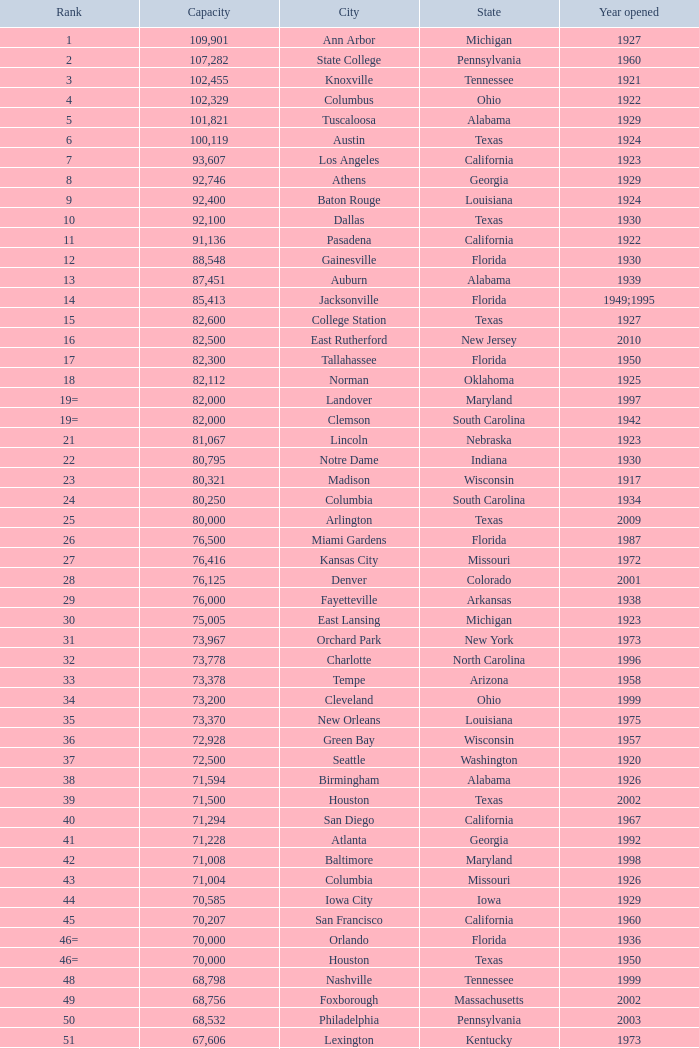What was the year opened for North Carolina with a smaller than 21,500 capacity? 1926.0. Would you be able to parse every entry in this table? {'header': ['Rank', 'Capacity', 'City', 'State', 'Year opened'], 'rows': [['1', '109,901', 'Ann Arbor', 'Michigan', '1927'], ['2', '107,282', 'State College', 'Pennsylvania', '1960'], ['3', '102,455', 'Knoxville', 'Tennessee', '1921'], ['4', '102,329', 'Columbus', 'Ohio', '1922'], ['5', '101,821', 'Tuscaloosa', 'Alabama', '1929'], ['6', '100,119', 'Austin', 'Texas', '1924'], ['7', '93,607', 'Los Angeles', 'California', '1923'], ['8', '92,746', 'Athens', 'Georgia', '1929'], ['9', '92,400', 'Baton Rouge', 'Louisiana', '1924'], ['10', '92,100', 'Dallas', 'Texas', '1930'], ['11', '91,136', 'Pasadena', 'California', '1922'], ['12', '88,548', 'Gainesville', 'Florida', '1930'], ['13', '87,451', 'Auburn', 'Alabama', '1939'], ['14', '85,413', 'Jacksonville', 'Florida', '1949;1995'], ['15', '82,600', 'College Station', 'Texas', '1927'], ['16', '82,500', 'East Rutherford', 'New Jersey', '2010'], ['17', '82,300', 'Tallahassee', 'Florida', '1950'], ['18', '82,112', 'Norman', 'Oklahoma', '1925'], ['19=', '82,000', 'Landover', 'Maryland', '1997'], ['19=', '82,000', 'Clemson', 'South Carolina', '1942'], ['21', '81,067', 'Lincoln', 'Nebraska', '1923'], ['22', '80,795', 'Notre Dame', 'Indiana', '1930'], ['23', '80,321', 'Madison', 'Wisconsin', '1917'], ['24', '80,250', 'Columbia', 'South Carolina', '1934'], ['25', '80,000', 'Arlington', 'Texas', '2009'], ['26', '76,500', 'Miami Gardens', 'Florida', '1987'], ['27', '76,416', 'Kansas City', 'Missouri', '1972'], ['28', '76,125', 'Denver', 'Colorado', '2001'], ['29', '76,000', 'Fayetteville', 'Arkansas', '1938'], ['30', '75,005', 'East Lansing', 'Michigan', '1923'], ['31', '73,967', 'Orchard Park', 'New York', '1973'], ['32', '73,778', 'Charlotte', 'North Carolina', '1996'], ['33', '73,378', 'Tempe', 'Arizona', '1958'], ['34', '73,200', 'Cleveland', 'Ohio', '1999'], ['35', '73,370', 'New Orleans', 'Louisiana', '1975'], ['36', '72,928', 'Green Bay', 'Wisconsin', '1957'], ['37', '72,500', 'Seattle', 'Washington', '1920'], ['38', '71,594', 'Birmingham', 'Alabama', '1926'], ['39', '71,500', 'Houston', 'Texas', '2002'], ['40', '71,294', 'San Diego', 'California', '1967'], ['41', '71,228', 'Atlanta', 'Georgia', '1992'], ['42', '71,008', 'Baltimore', 'Maryland', '1998'], ['43', '71,004', 'Columbia', 'Missouri', '1926'], ['44', '70,585', 'Iowa City', 'Iowa', '1929'], ['45', '70,207', 'San Francisco', 'California', '1960'], ['46=', '70,000', 'Orlando', 'Florida', '1936'], ['46=', '70,000', 'Houston', 'Texas', '1950'], ['48', '68,798', 'Nashville', 'Tennessee', '1999'], ['49', '68,756', 'Foxborough', 'Massachusetts', '2002'], ['50', '68,532', 'Philadelphia', 'Pennsylvania', '2003'], ['51', '67,606', 'Lexington', 'Kentucky', '1973'], ['52', '67,000', 'Seattle', 'Washington', '2002'], ['53', '66,965', 'St. Louis', 'Missouri', '1995'], ['54', '66,233', 'Blacksburg', 'Virginia', '1965'], ['55', '65,857', 'Tampa', 'Florida', '1998'], ['56', '65,790', 'Cincinnati', 'Ohio', '2000'], ['57', '65,050', 'Pittsburgh', 'Pennsylvania', '2001'], ['58=', '65,000', 'San Antonio', 'Texas', '1993'], ['58=', '65,000', 'Detroit', 'Michigan', '2002'], ['60', '64,269', 'New Haven', 'Connecticut', '1914'], ['61', '64,111', 'Minneapolis', 'Minnesota', '1982'], ['62', '64,045', 'Provo', 'Utah', '1964'], ['63', '63,400', 'Glendale', 'Arizona', '2006'], ['64', '63,026', 'Oakland', 'California', '1966'], ['65', '63,000', 'Indianapolis', 'Indiana', '2008'], ['65', '63.000', 'Chapel Hill', 'North Carolina', '1926'], ['66', '62,872', 'Champaign', 'Illinois', '1923'], ['67', '62,717', 'Berkeley', 'California', '1923'], ['68', '61,500', 'Chicago', 'Illinois', '1924;2003'], ['69', '62,500', 'West Lafayette', 'Indiana', '1924'], ['70', '62,380', 'Memphis', 'Tennessee', '1965'], ['71', '61,500', 'Charlottesville', 'Virginia', '1931'], ['72', '61,000', 'Lubbock', 'Texas', '1947'], ['73', '60,580', 'Oxford', 'Mississippi', '1915'], ['74', '60,540', 'Morgantown', 'West Virginia', '1980'], ['75', '60,492', 'Jackson', 'Mississippi', '1941'], ['76', '60,000', 'Stillwater', 'Oklahoma', '1920'], ['78', '57,803', 'Tucson', 'Arizona', '1928'], ['79', '57,583', 'Raleigh', 'North Carolina', '1966'], ['80', '56,692', 'Washington, D.C.', 'District of Columbia', '1961'], ['81=', '56,000', 'Los Angeles', 'California', '1962'], ['81=', '56,000', 'Louisville', 'Kentucky', '1998'], ['83', '55,082', 'Starkville', 'Mississippi', '1914'], ['84=', '55,000', 'Atlanta', 'Georgia', '1913'], ['84=', '55,000', 'Ames', 'Iowa', '1975'], ['86', '53,800', 'Eugene', 'Oregon', '1967'], ['87', '53,750', 'Boulder', 'Colorado', '1924'], ['88', '53,727', 'Little Rock', 'Arkansas', '1948'], ['89', '53,500', 'Bloomington', 'Indiana', '1960'], ['90', '52,593', 'Philadelphia', 'Pennsylvania', '1895'], ['91', '52,480', 'Colorado Springs', 'Colorado', '1962'], ['92', '52,454', 'Piscataway', 'New Jersey', '1994'], ['93', '52,200', 'Manhattan', 'Kansas', '1968'], ['94=', '51,500', 'College Park', 'Maryland', '1950'], ['94=', '51,500', 'El Paso', 'Texas', '1963'], ['96', '50,832', 'Shreveport', 'Louisiana', '1925'], ['97', '50,805', 'Minneapolis', 'Minnesota', '2009'], ['98', '50,445', 'Denver', 'Colorado', '1995'], ['99', '50,291', 'Bronx', 'New York', '2009'], ['100', '50,096', 'Atlanta', 'Georgia', '1996'], ['101', '50,071', 'Lawrence', 'Kansas', '1921'], ['102=', '50,000', 'Honolulu', 'Hawai ʻ i', '1975'], ['102=', '50,000', 'Greenville', 'North Carolina', '1963'], ['102=', '50,000', 'Waco', 'Texas', '1950'], ['102=', '50,000', 'Stanford', 'California', '1921;2006'], ['106', '49,262', 'Syracuse', 'New York', '1980'], ['107', '49,115', 'Arlington', 'Texas', '1994'], ['108', '49,033', 'Phoenix', 'Arizona', '1998'], ['109', '48,876', 'Baltimore', 'Maryland', '1992'], ['110', '47,130', 'Evanston', 'Illinois', '1996'], ['111', '47,116', 'Seattle', 'Washington', '1999'], ['112', '46,861', 'St. Louis', 'Missouri', '2006'], ['113', '45,674', 'Corvallis', 'Oregon', '1953'], ['114', '45,634', 'Salt Lake City', 'Utah', '1998'], ['115', '45,301', 'Orlando', 'Florida', '2007'], ['116', '45,050', 'Anaheim', 'California', '1966'], ['117', '44,500', 'Chestnut Hill', 'Massachusetts', '1957'], ['118', '44,008', 'Fort Worth', 'Texas', '1930'], ['119', '43,647', 'Philadelphia', 'Pennsylvania', '2004'], ['120', '43,545', 'Cleveland', 'Ohio', '1994'], ['121', '42,445', 'San Diego', 'California', '2004'], ['122', '42,059', 'Cincinnati', 'Ohio', '2003'], ['123', '41,900', 'Milwaukee', 'Wisconsin', '2001'], ['124', '41,888', 'Washington, D.C.', 'District of Columbia', '2008'], ['125', '41,800', 'Flushing, New York', 'New York', '2009'], ['126', '41,782', 'Detroit', 'Michigan', '2000'], ['127', '41,503', 'San Francisco', 'California', '2000'], ['128', '41,160', 'Chicago', 'Illinois', '1914'], ['129', '41,031', 'Fresno', 'California', '1980'], ['130', '40,950', 'Houston', 'Texas', '2000'], ['131', '40,646', 'Mobile', 'Alabama', '1948'], ['132', '40,615', 'Chicago', 'Illinois', '1991'], ['133', '40,094', 'Albuquerque', 'New Mexico', '1960'], ['134=', '40,000', 'South Williamsport', 'Pennsylvania', '1959'], ['134=', '40,000', 'East Hartford', 'Connecticut', '2003'], ['134=', '40,000', 'West Point', 'New York', '1924'], ['137', '39,790', 'Nashville', 'Tennessee', '1922'], ['138', '39,504', 'Minneapolis', 'Minnesota', '2010'], ['139', '39,000', 'Kansas City', 'Missouri', '1973'], ['140', '38,496', 'Pittsburgh', 'Pennsylvania', '2001'], ['141', '38,019', 'Huntington', 'West Virginia', '1991'], ['142', '37,402', 'Boston', 'Massachusetts', '1912'], ['143=', '37,000', 'Boise', 'Idaho', '1970'], ['143=', '37,000', 'Miami', 'Florida', '2012'], ['145', '36,973', 'St. Petersburg', 'Florida', '1990'], ['146', '36,800', 'Whitney', 'Nevada', '1971'], ['147', '36,000', 'Hattiesburg', 'Mississippi', '1932'], ['148', '35,117', 'Pullman', 'Washington', '1972'], ['149', '35,097', 'Cincinnati', 'Ohio', '1924'], ['150', '34,400', 'Fort Collins', 'Colorado', '1968'], ['151', '34,000', 'Annapolis', 'Maryland', '1959'], ['152', '33,941', 'Durham', 'North Carolina', '1929'], ['153', '32,580', 'Laramie', 'Wyoming', '1950'], ['154=', '32,000', 'University Park', 'Texas', '2000'], ['154=', '32,000', 'Houston', 'Texas', '1942'], ['156', '31,500', 'Winston-Salem', 'North Carolina', '1968'], ['157=', '31,000', 'Lafayette', 'Louisiana', '1971'], ['157=', '31,000', 'Akron', 'Ohio', '1940'], ['157=', '31,000', 'DeKalb', 'Illinois', '1965'], ['160', '30,964', 'Jonesboro', 'Arkansas', '1974'], ['161', '30,850', 'Denton', 'Texas', '2011'], ['162', '30,600', 'Ruston', 'Louisiana', '1960'], ['163', '30,456', 'San Jose', 'California', '1933'], ['164', '30,427', 'Monroe', 'Louisiana', '1978'], ['165', '30,343', 'Las Cruces', 'New Mexico', '1978'], ['166', '30,323', 'Allston', 'Massachusetts', '1903'], ['167', '30,295', 'Mount Pleasant', 'Michigan', '1972'], ['168=', '30,200', 'Ypsilanti', 'Michigan', '1969'], ['168=', '30,200', 'Kalamazoo', 'Michigan', '1939'], ['168=', '30,000', 'Boca Raton', 'Florida', '2011'], ['168=', '30,000', 'San Marcos', 'Texas', '1981'], ['168=', '30,000', 'Tulsa', 'Oklahoma', '1930'], ['168=', '30,000', 'Akron', 'Ohio', '2009'], ['168=', '30,000', 'Troy', 'Alabama', '1950'], ['168=', '30,000', 'Norfolk', 'Virginia', '1997'], ['176', '29,993', 'Reno', 'Nevada', '1966'], ['177', '29,013', 'Amherst', 'New York', '1993'], ['178', '29,000', 'Baton Rouge', 'Louisiana', '1928'], ['179', '28,646', 'Spokane', 'Washington', '1950'], ['180', '27,800', 'Princeton', 'New Jersey', '1998'], ['181', '27,000', 'Carson', 'California', '2003'], ['182', '26,248', 'Toledo', 'Ohio', '1937'], ['183', '25,600', 'Grambling', 'Louisiana', '1983'], ['184', '25,597', 'Ithaca', 'New York', '1915'], ['185', '25,500', 'Tallahassee', 'Florida', '1957'], ['186', '25,400', 'Muncie', 'Indiana', '1967'], ['187', '25,200', 'Missoula', 'Montana', '1986'], ['188', '25,189', 'Harrison', 'New Jersey', '2010'], ['189', '25,000', 'Kent', 'Ohio', '1969'], ['190', '24,877', 'Harrisonburg', 'Virginia', '1975'], ['191', '24,600', 'Montgomery', 'Alabama', '1922'], ['192', '24,286', 'Oxford', 'Ohio', '1983'], ['193=', '24,000', 'Omaha', 'Nebraska', '2011'], ['193=', '24,000', 'Athens', 'Ohio', '1929'], ['194', '23,724', 'Bowling Green', 'Ohio', '1966'], ['195', '23,500', 'Worcester', 'Massachusetts', '1924'], ['196', '22,500', 'Lorman', 'Mississippi', '1992'], ['197=', '22,000', 'Houston', 'Texas', '2012'], ['197=', '22,000', 'Newark', 'Delaware', '1952'], ['197=', '22,000', 'Bowling Green', 'Kentucky', '1968'], ['197=', '22,000', 'Orangeburg', 'South Carolina', '1955'], ['201', '21,650', 'Boone', 'North Carolina', '1962'], ['202', '21,500', 'Greensboro', 'North Carolina', '1981'], ['203', '21,650', 'Sacramento', 'California', '1969'], ['204=', '21,000', 'Charleston', 'South Carolina', '1946'], ['204=', '21,000', 'Huntsville', 'Alabama', '1996'], ['204=', '21,000', 'Chicago', 'Illinois', '1994'], ['207', '20,668', 'Chattanooga', 'Tennessee', '1997'], ['208', '20,630', 'Youngstown', 'Ohio', '1982'], ['209', '20,500', 'Frisco', 'Texas', '2005'], ['210', '20,455', 'Columbus', 'Ohio', '1999'], ['211', '20,450', 'Fort Lauderdale', 'Florida', '1959'], ['212', '20,438', 'Portland', 'Oregon', '1926'], ['213', '20,311', 'Sacramento, California', 'California', '1928'], ['214', '20,066', 'Detroit, Michigan', 'Michigan', '1979'], ['215', '20,008', 'Sandy', 'Utah', '2008'], ['216=', '20,000', 'Providence', 'Rhode Island', '1925'], ['216=', '20,000', 'Miami', 'Florida', '1995'], ['216=', '20,000', 'Richmond', 'Kentucky', '1969'], ['216=', '20,000', 'Mesquite', 'Texas', '1977'], ['216=', '20,000', 'Canyon', 'Texas', '1959'], ['216=', '20,000', 'Bridgeview', 'Illinois', '2006']]} 